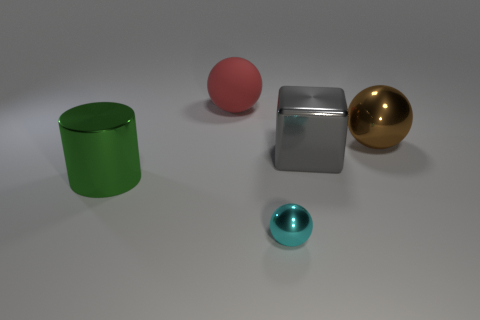Add 3 small gray metallic balls. How many objects exist? 8 Subtract all cylinders. How many objects are left? 4 Subtract 0 cyan cubes. How many objects are left? 5 Subtract all big brown things. Subtract all large cubes. How many objects are left? 3 Add 1 big gray cubes. How many big gray cubes are left? 2 Add 3 large yellow shiny objects. How many large yellow shiny objects exist? 3 